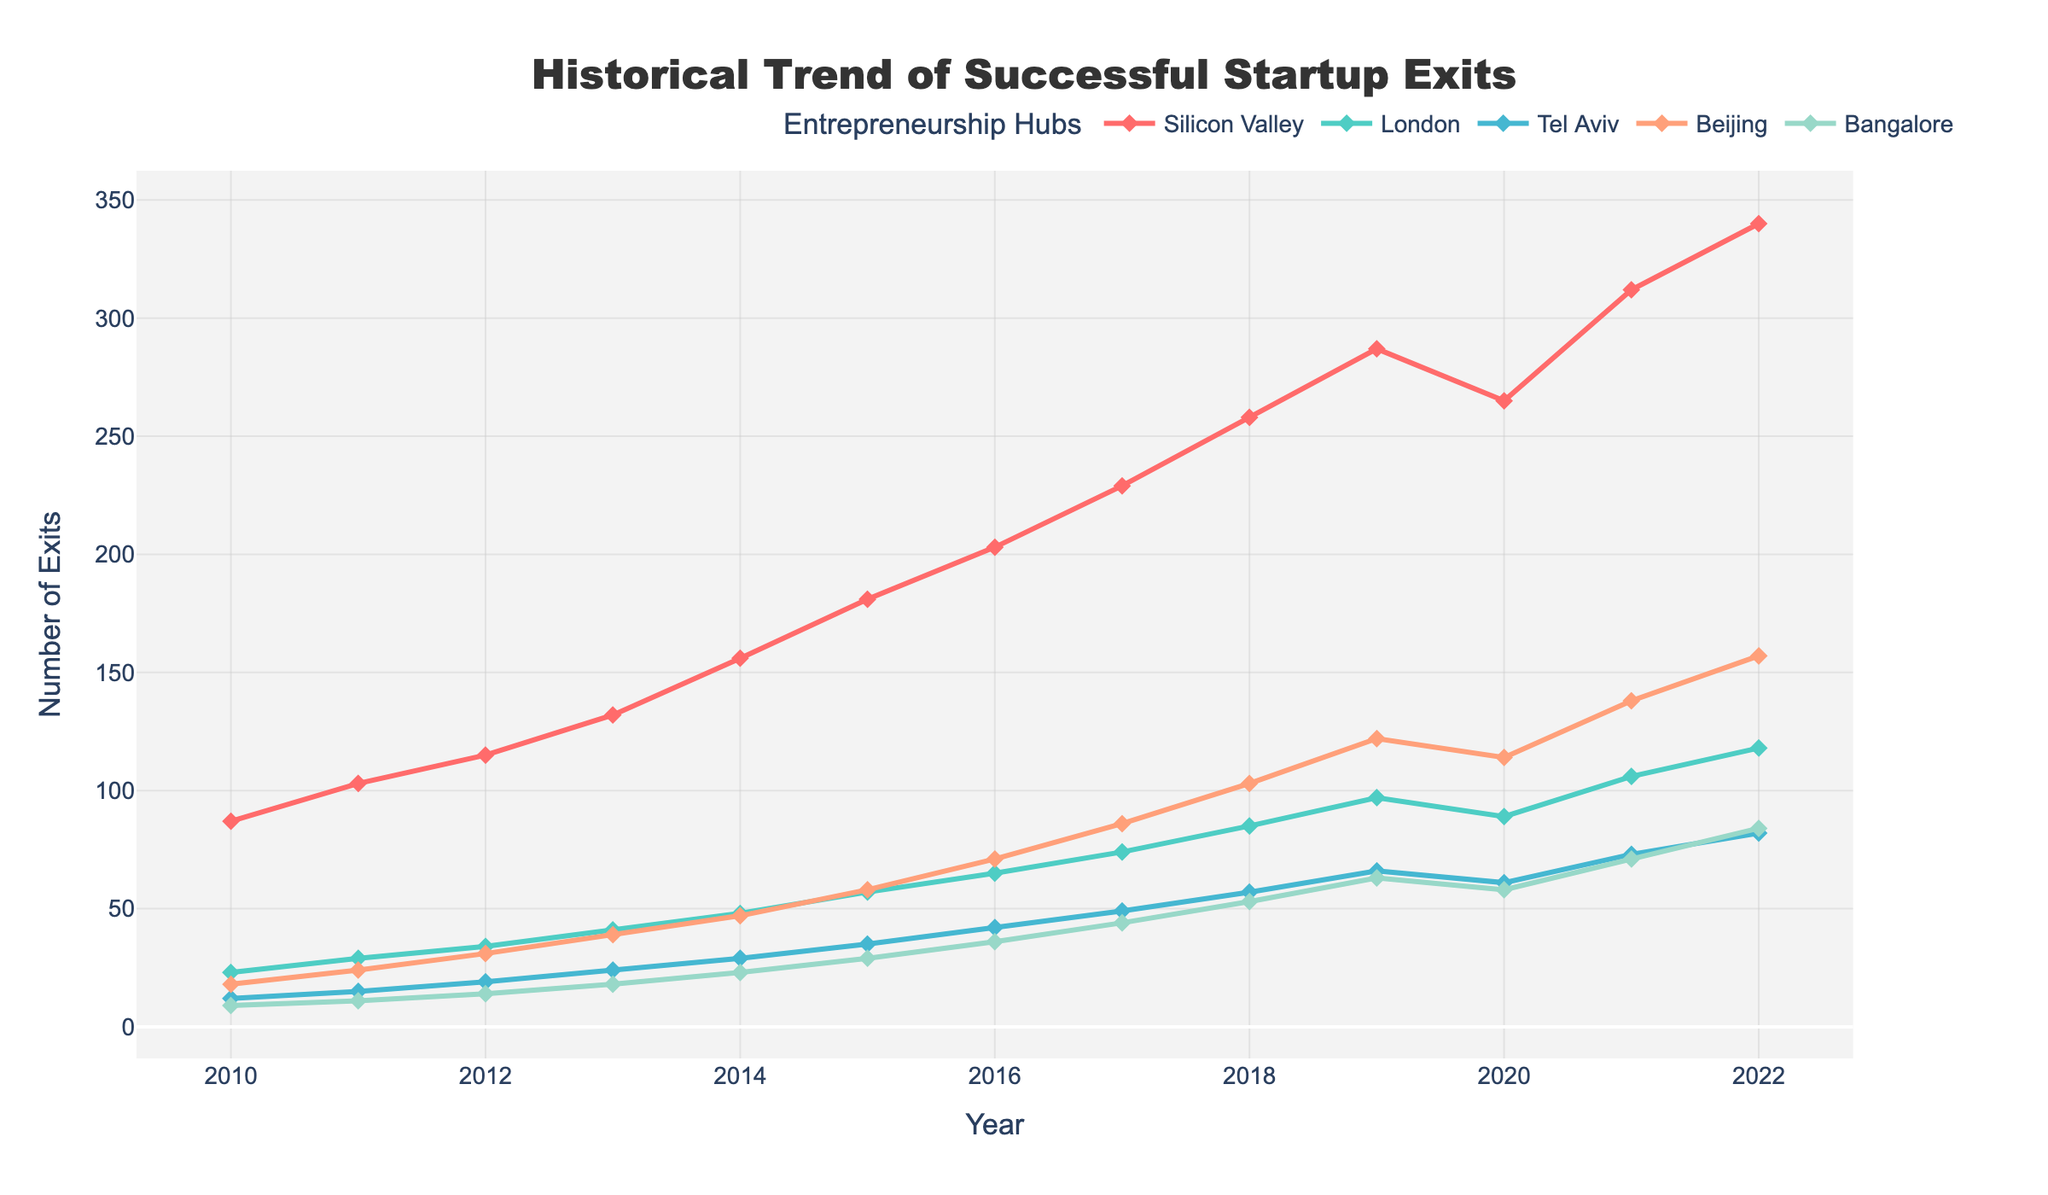What's the highest number of successful startup exits in Silicon Valley? The highest number can be directly read from the graph where the line for Silicon Valley reaches its peak. This occurs in the year 2022.
Answer: 340 Which entrepreneurship hub had the smallest number of exits in 2010? To find this, we examine the data points for each hub in 2010. Among Silicon Valley (87), London (23), Tel Aviv (12), Beijing (18), and Bangalore (9), Bangalore had the smallest number.
Answer: Bangalore How many total successful startup exits were there in all hubs in 2014? To find the total number of exits for 2014, sum the values for each hub: Silicon Valley (156), London (48), Tel Aviv (29), Beijing (47), and Bangalore (23). 156 + 48 + 29 + 47 + 23 = 303.
Answer: 303 Which hub saw the largest increase in the number of exits from 2019 to 2022? To find this, calculate the difference in the number of exits between 2019 and 2022 for each hub and determine the largest value: 
Silicon Valley: 340 - 287 = 53,
London: 118 - 97 = 21,
Tel Aviv: 82 - 66 = 16,
Beijing: 157 - 122 = 35,
Bangalore: 84 - 63 = 21.
Silicon Valley has the largest increase.
Answer: Silicon Valley In which year did Bangalore surpass 50 successful startup exits? We look at Bangalore's data points through the years and find that Bangalore reached 53 exits in 2018, surpassing 50 for the first time.
Answer: 2018 How many more successful startup exits did Beijing have than London in 2020? To find the difference in 2020, subtract London's exits from Beijing's exits: Beijing (114) - London (89) = 25.
Answer: 25 What is the average number of successful startup exits in Tel Aviv across the entire period? First, sum the total number of exits for Tel Aviv from 2010 to 2022 and then divide by the number of years (13). 
Total = 12 + 15 + 19 + 24 + 29 + 35 + 42 + 49 + 57 + 66 + 61 + 73 + 82 = 564, 
Average = 564 / 13 = 43.38.
Answer: 43.38 Which year did Silicon Valley reach at least 200 successful exits for the first time? Examine Silicon Valley's data points and identify the first year that reaches or surpasses 200 entries, which is 2016.
Answer: 2016 Comparing 2020 and 2021, which hub saw the highest percentage increase in successful exits? Calculate the percentage increase for each hub between 2020 and 2021:
Silicon Valley: ((312 - 265) / 265) * 100 ≈ 17.7%,
London: ((106 - 89) / 89) * 100 ≈ 19.1%,
Tel Aviv: ((73 - 61) / 61) * 100 ≈ 19.7%,
Beijing: ((138 - 114) / 114) * 100 ≈ 21.1%,
Bangalore: ((71 - 58) / 58) * 100 ≈ 22.4%.
Bangalore had the highest percentage increase.
Answer: Bangalore 